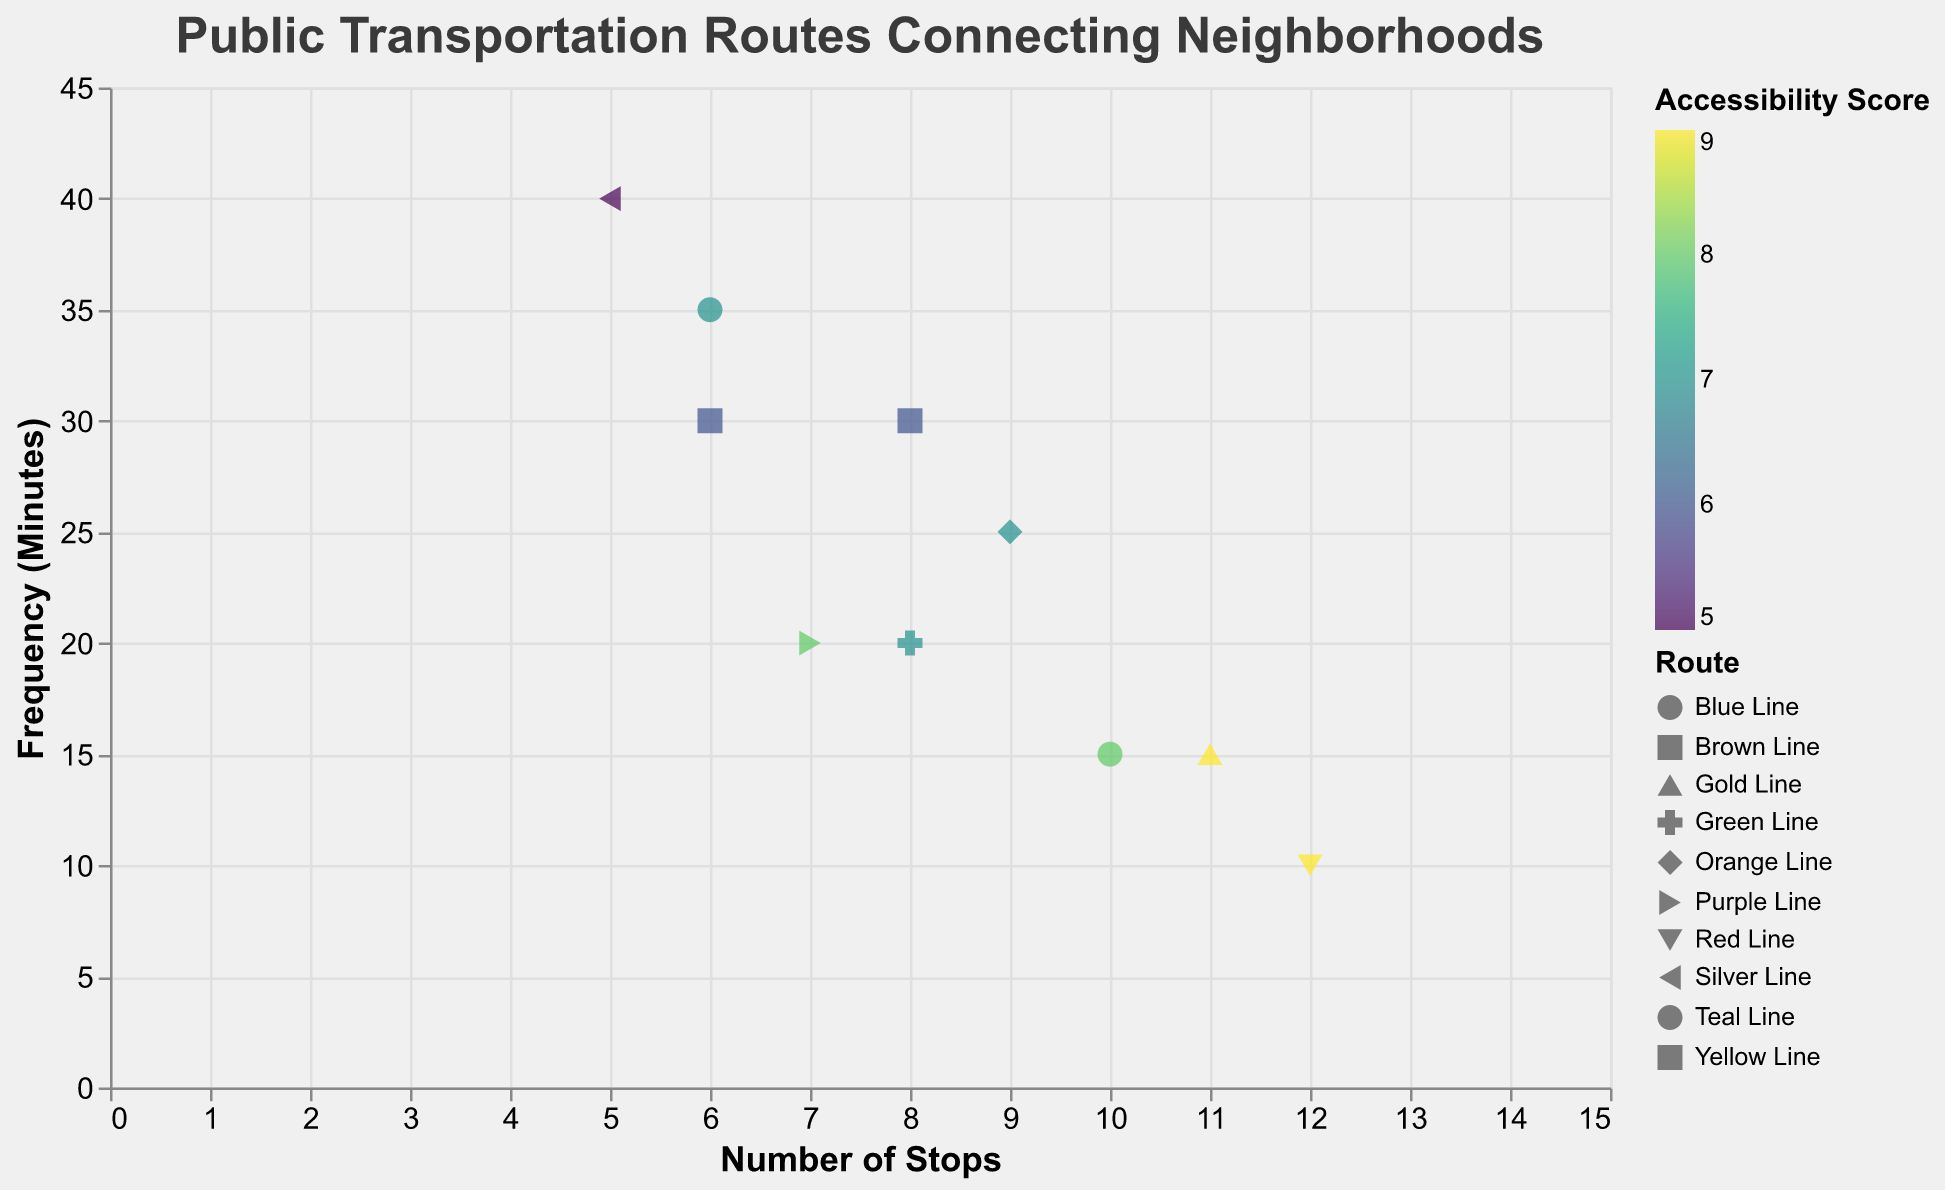What is the title of the plot? The title can be found at the top of the plot. It is usually highlighted with larger font size.
Answer: Public Transportation Routes Connecting Neighborhoods How many routes have an accessibility score of 9? Look at the color legend for Accessibility Score and find the color corresponding to an accessibility score of 9. Identify the number of data points (shapes) with that color.
Answer: Two Which route has the highest number of stops? Check the x-axis for the data point (route) that is farthest to the right since more stops mean a higher x-axis value.
Answer: Red Line What is the frequency of the Purple Line? Find the Purple Line in the legend and identify the corresponding data point. Then read the frequency value on the y-axis for that point.
Answer: 20 minutes Which route connects the most distant neighborhoods in terms of fewer stops and high frequency? Evaluate routes with fewer stops and a high y-axis value for frequency. Fewer stops mean a lower x-axis value, while higher frequency refers to a higher y-axis value. Compare data points in the lower-left quadrant of the plot.
Answer: Silver Line Which two routes have the same number of stops but different frequencies? Look for data points with the same x-axis value (number of stops) but different y-axis values (frequency).
Answer: Green Line and Brown Line What is the average accessibility score of all routes? Sum all the accessibility scores given in the tooltip and divide by the number of routes. (8 + 7 + 9 + 6 + 7 + 8 + 5 + 9 + 6 + 7) / 10 = 72 / 10
Answer: 7.2 Which two routes are closest in terms of frequency? Identify data points that are closest in position along the y-axis, representing frequency.
Answer: Green Line and Purple Line Which route serves the Downtown area and how frequent is its service? Find the route that has "Downtown" as the end neighborhood in the tooltip and identify its frequency on the y-axis.
Answer: Blue Line, 15 minutes How does the accessibility score trend correlate with the frequency of routes? Observe the color gradient in relation to the positioning on the y-axis from higher (greenish) to lower (purplish) scores. Note general trends, e.g., higher y-axis values may correspond to lower accessibility scores.
Answer: Higher frequency often corresponds to lower accessibility scores 